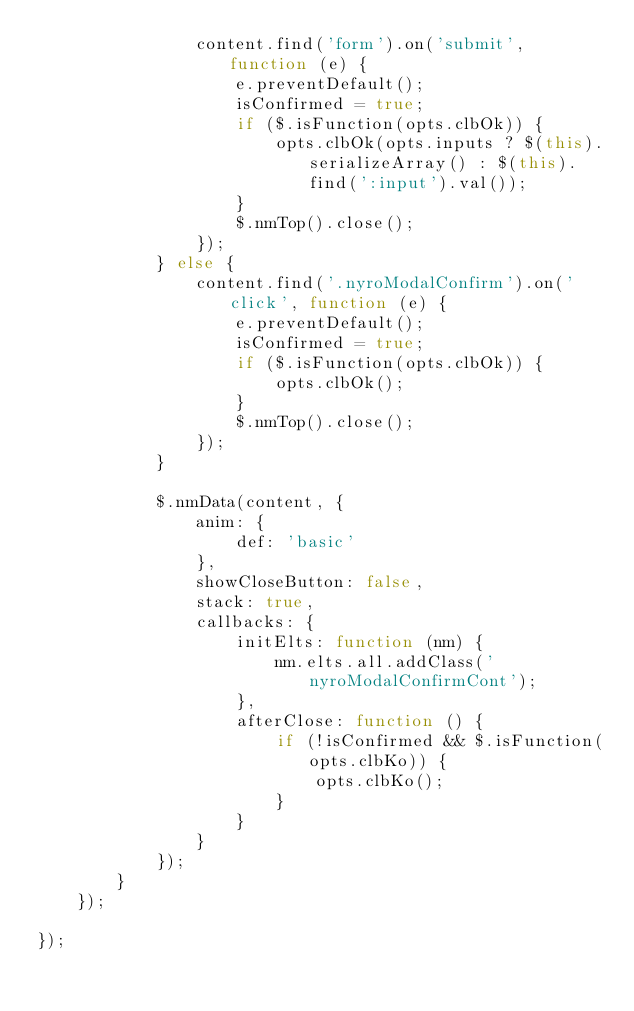<code> <loc_0><loc_0><loc_500><loc_500><_JavaScript_>				content.find('form').on('submit', function (e) {
					e.preventDefault();
					isConfirmed = true;
					if ($.isFunction(opts.clbOk)) {
						opts.clbOk(opts.inputs ? $(this).serializeArray() : $(this).find(':input').val());
					}
					$.nmTop().close();
				});
			} else {
				content.find('.nyroModalConfirm').on('click', function (e) {
					e.preventDefault();
					isConfirmed = true;
					if ($.isFunction(opts.clbOk)) {
						opts.clbOk();
					}
					$.nmTop().close();
				});
			}

			$.nmData(content, {
				anim: {
					def: 'basic'
				},
				showCloseButton: false,
				stack: true,
				callbacks: {
					initElts: function (nm) {
						nm.elts.all.addClass('nyroModalConfirmCont');
					},
					afterClose: function () {
						if (!isConfirmed && $.isFunction(opts.clbKo)) {
							opts.clbKo();
						}
					}
				}
			});
		}
	});

});</code> 